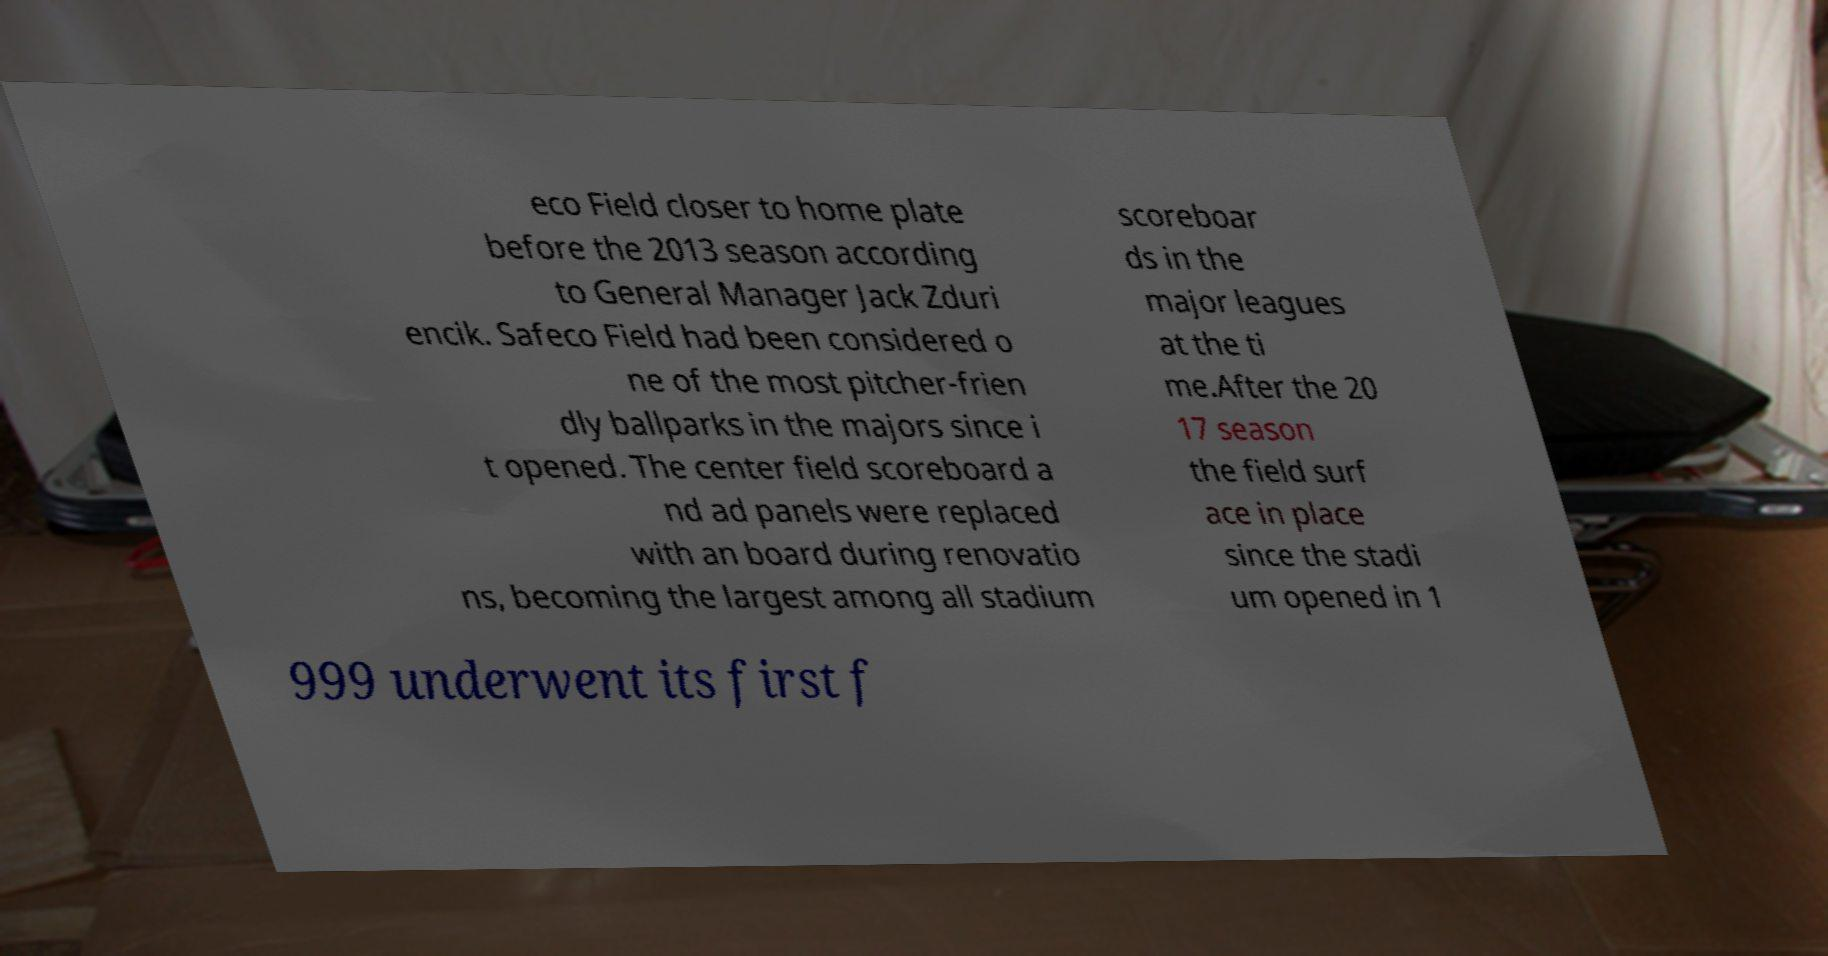Please identify and transcribe the text found in this image. eco Field closer to home plate before the 2013 season according to General Manager Jack Zduri encik. Safeco Field had been considered o ne of the most pitcher-frien dly ballparks in the majors since i t opened. The center field scoreboard a nd ad panels were replaced with an board during renovatio ns, becoming the largest among all stadium scoreboar ds in the major leagues at the ti me.After the 20 17 season the field surf ace in place since the stadi um opened in 1 999 underwent its first f 